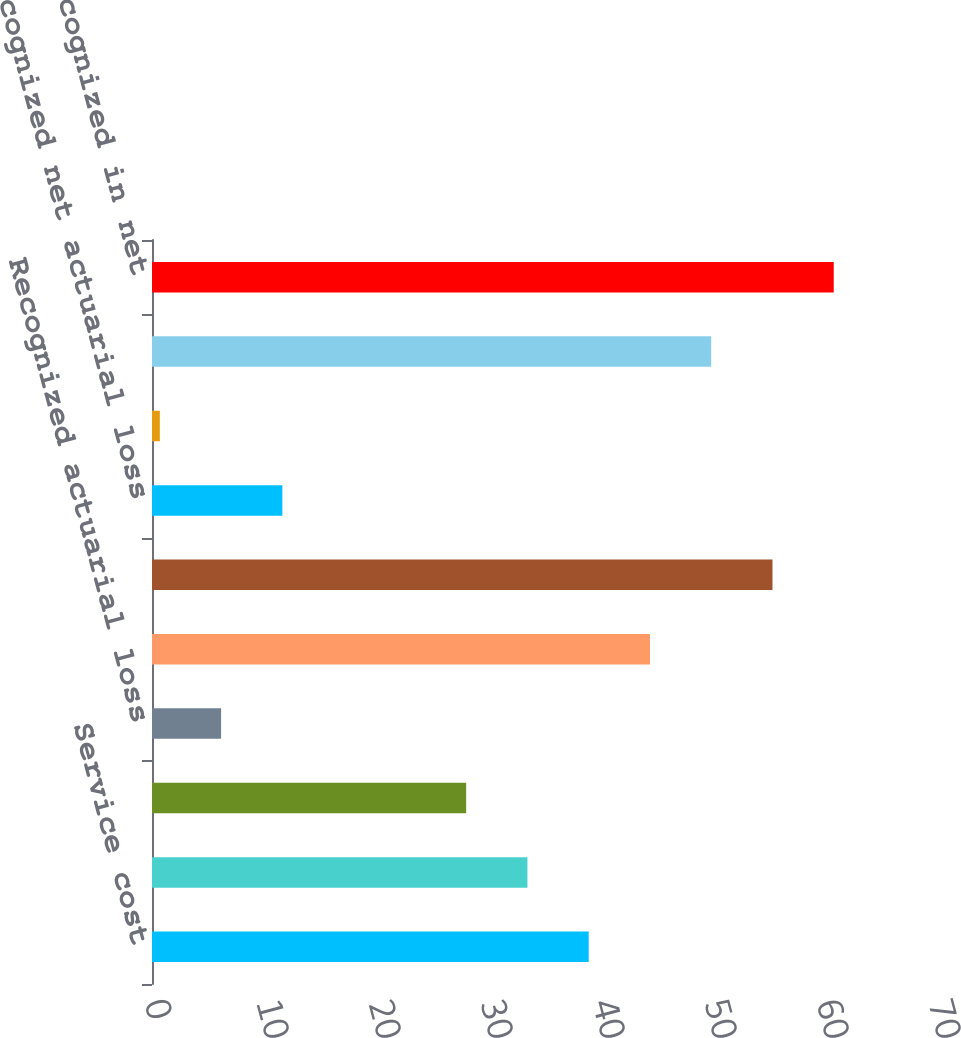Convert chart. <chart><loc_0><loc_0><loc_500><loc_500><bar_chart><fcel>Service cost<fcel>Interest cost<fcel>Expected return on plan assets<fcel>Recognized actuarial loss<fcel>Net periodic benefit cost<fcel>Net actuarial gain (loss)<fcel>Recognized net actuarial loss<fcel>Prior service cost and<fcel>Total recognized in other<fcel>Total recognized in net<nl><fcel>38.99<fcel>33.52<fcel>28.05<fcel>6.17<fcel>44.46<fcel>55.4<fcel>11.64<fcel>0.7<fcel>49.93<fcel>60.87<nl></chart> 